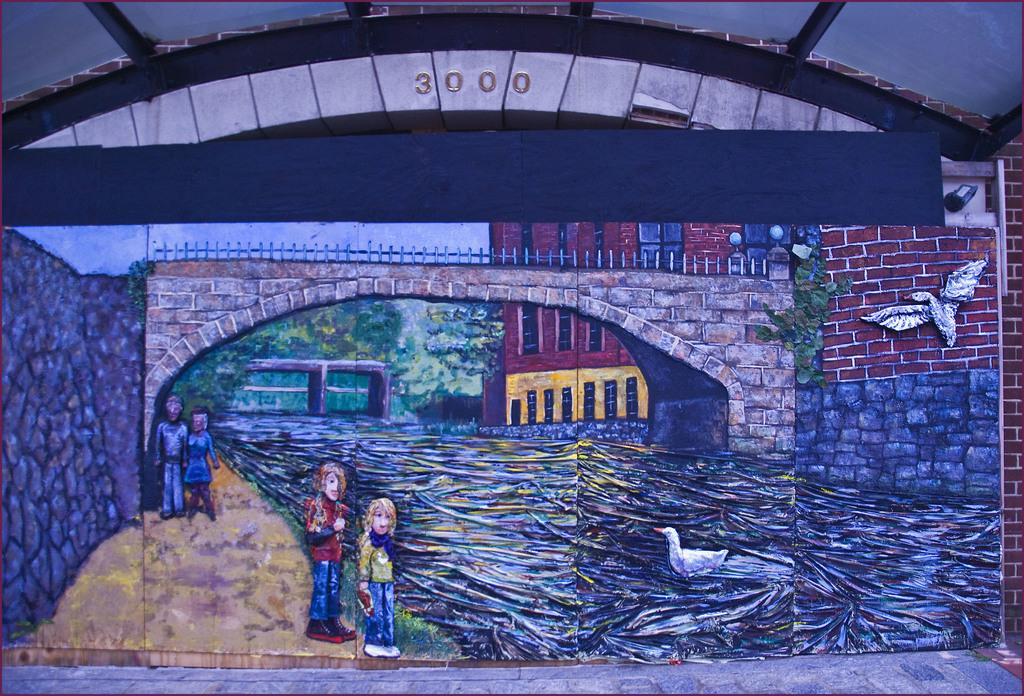Can you describe this image briefly? In this image I can see a painting and above it I can see few numbers are written. I can see the painting is of water, few birds, few people, few trees and few buildings. 